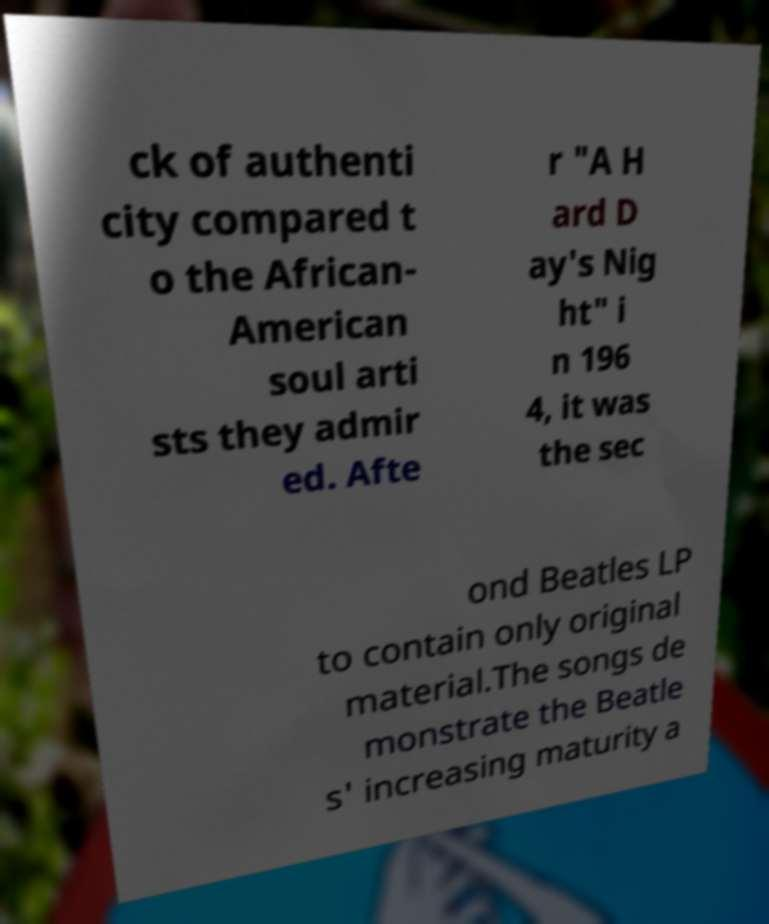Could you extract and type out the text from this image? ck of authenti city compared t o the African- American soul arti sts they admir ed. Afte r "A H ard D ay's Nig ht" i n 196 4, it was the sec ond Beatles LP to contain only original material.The songs de monstrate the Beatle s' increasing maturity a 